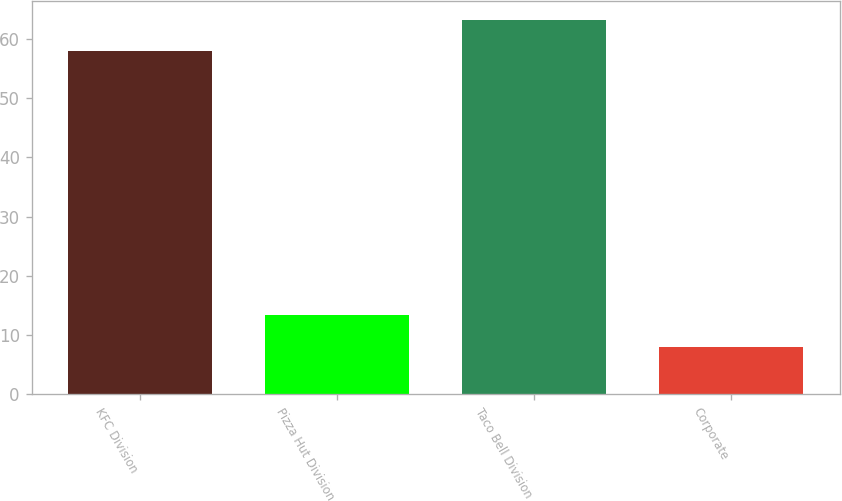Convert chart. <chart><loc_0><loc_0><loc_500><loc_500><bar_chart><fcel>KFC Division<fcel>Pizza Hut Division<fcel>Taco Bell Division<fcel>Corporate<nl><fcel>58<fcel>13.3<fcel>63.3<fcel>8<nl></chart> 